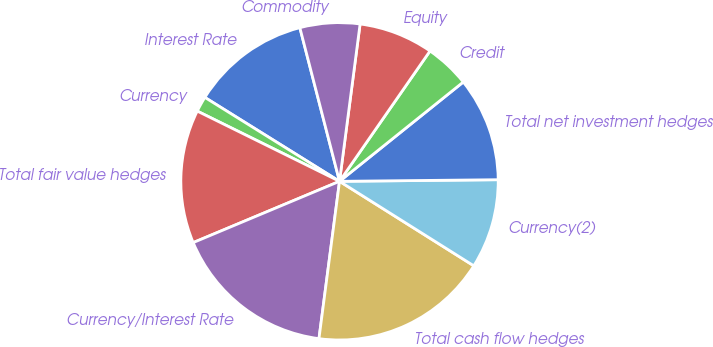<chart> <loc_0><loc_0><loc_500><loc_500><pie_chart><fcel>Interest Rate<fcel>Currency<fcel>Total fair value hedges<fcel>Currency/Interest Rate<fcel>Total cash flow hedges<fcel>Currency(2)<fcel>Total net investment hedges<fcel>Credit<fcel>Equity<fcel>Commodity<nl><fcel>12.11%<fcel>1.57%<fcel>13.61%<fcel>16.62%<fcel>18.13%<fcel>9.1%<fcel>10.6%<fcel>4.58%<fcel>7.59%<fcel>6.09%<nl></chart> 